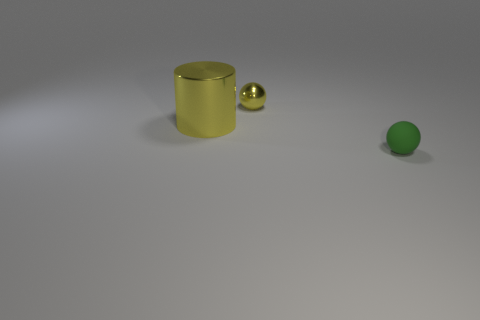Add 1 blue shiny blocks. How many objects exist? 4 Subtract all cylinders. How many objects are left? 2 Add 2 large yellow cylinders. How many large yellow cylinders exist? 3 Subtract 0 gray balls. How many objects are left? 3 Subtract all tiny green cylinders. Subtract all tiny matte objects. How many objects are left? 2 Add 3 cylinders. How many cylinders are left? 4 